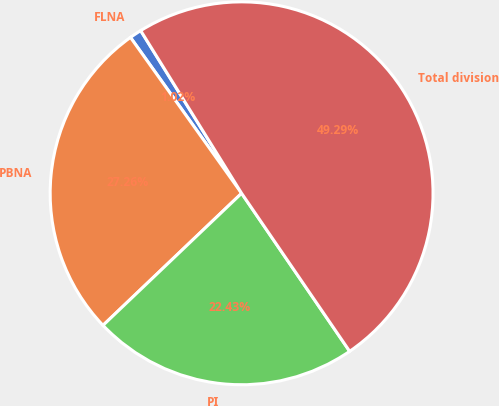Convert chart to OTSL. <chart><loc_0><loc_0><loc_500><loc_500><pie_chart><fcel>FLNA<fcel>PBNA<fcel>PI<fcel>Total division<nl><fcel>1.02%<fcel>27.26%<fcel>22.43%<fcel>49.29%<nl></chart> 